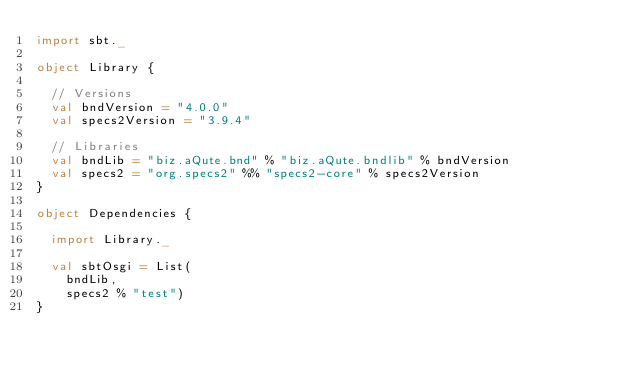<code> <loc_0><loc_0><loc_500><loc_500><_Scala_>import sbt._

object Library {

  // Versions
  val bndVersion = "4.0.0"
  val specs2Version = "3.9.4"

  // Libraries
  val bndLib = "biz.aQute.bnd" % "biz.aQute.bndlib" % bndVersion
  val specs2 = "org.specs2" %% "specs2-core" % specs2Version
}

object Dependencies {

  import Library._

  val sbtOsgi = List(
    bndLib,
    specs2 % "test")
}
</code> 